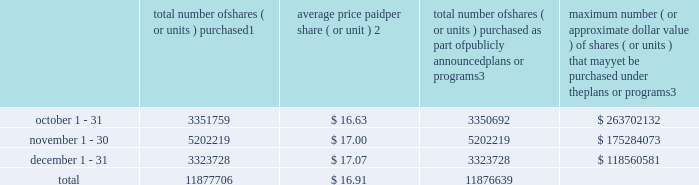Transfer agent and registrar for common stock the transfer agent and registrar for our common stock is : computershare shareowner services llc 480 washington boulevard 29th floor jersey city , new jersey 07310 telephone : ( 877 ) 363-6398 sales of unregistered securities not applicable .
Repurchase of equity securities the table provides information regarding our purchases of our equity securities during the period from october 1 , 2013 to december 31 , 2013 .
Total number of shares ( or units ) purchased 1 average price paid per share ( or unit ) 2 total number of shares ( or units ) purchased as part of publicly announced plans or programs 3 maximum number ( or approximate dollar value ) of shares ( or units ) that may yet be purchased under the plans or programs 3 .
1 includes shares of our common stock , par value $ 0.10 per share , withheld under the terms of grants under employee stock-based compensation plans to offset tax withholding obligations that occurred upon vesting and release of restricted shares ( the 201cwithheld shares 201d ) .
We repurchased 1067 withheld shares in october 2013 .
No withheld shares were purchased in november or december of 2013 .
2 the average price per share for each of the months in the fiscal quarter and for the three-month period was calculated by dividing the sum of the applicable period of the aggregate value of the tax withholding obligations and the aggregate amount we paid for shares acquired under our stock repurchase program , described in note 6 to the consolidated financial statements , by the sum of the number of withheld shares and the number of shares acquired in our stock repurchase program .
3 in february 2013 , the board authorized a new share repurchase program to repurchase from time to time up to $ 300.0 million , excluding fees , of our common stock ( the 201c2013 share repurchase program 201d ) .
In march 2013 , the board authorized an increase in the amount available under our 2013 share repurchase program up to $ 500.0 million , excluding fees , of our common stock .
On february 14 , 2014 , we announced that our board had approved a new share repurchase program to repurchase from time to time up to $ 300.0 million , excluding fees , of our common stock .
The new authorization is in addition to any amounts remaining available for repurchase under the 2013 share repurchase program .
There is no expiration date associated with the share repurchase programs. .
What is the total amount of cash used for the repurchase of shares during november? 
Computations: (5202219 * 17.00)
Answer: 88437723.0. 